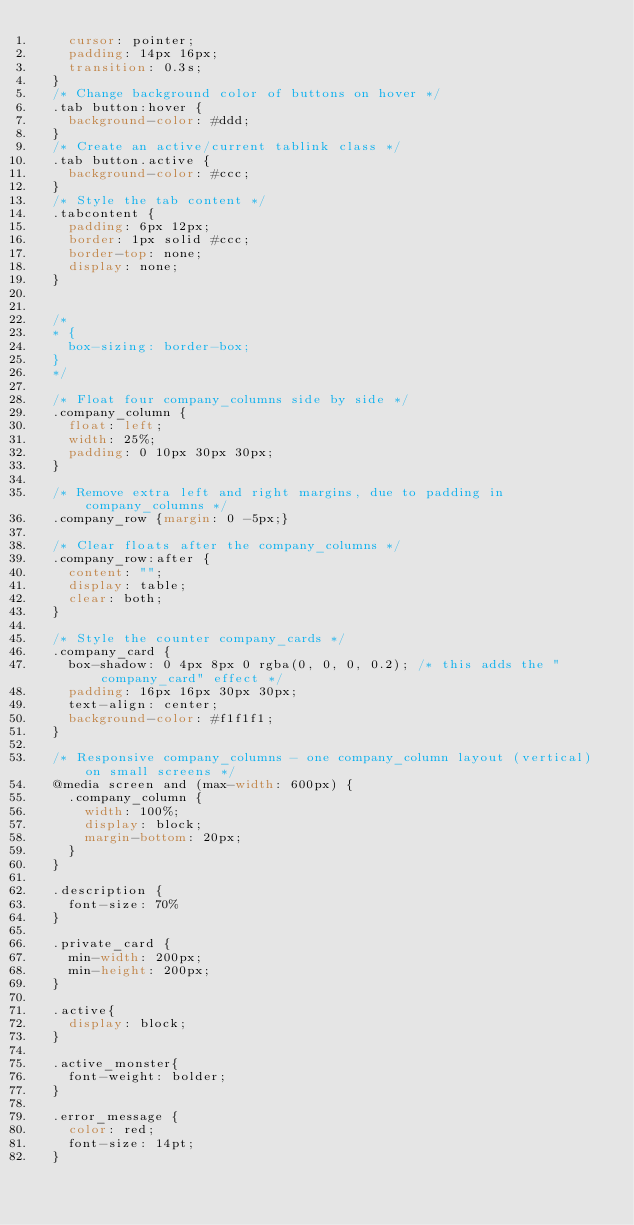<code> <loc_0><loc_0><loc_500><loc_500><_CSS_>    cursor: pointer;
    padding: 14px 16px;
    transition: 0.3s;
  }
  /* Change background color of buttons on hover */
  .tab button:hover {
    background-color: #ddd;
  }
  /* Create an active/current tablink class */
  .tab button.active {
    background-color: #ccc;
  }
  /* Style the tab content */
  .tabcontent {
    padding: 6px 12px;
    border: 1px solid #ccc;
    border-top: none;
    display: none;
  }


  /*
  * {
    box-sizing: border-box;
  }
  */

  /* Float four company_columns side by side */
  .company_column {
    float: left;
    width: 25%;
    padding: 0 10px 30px 30px;
  }
  
  /* Remove extra left and right margins, due to padding in company_columns */
  .company_row {margin: 0 -5px;}
  
  /* Clear floats after the company_columns */
  .company_row:after {
    content: "";
    display: table;
    clear: both;
  }
  
  /* Style the counter company_cards */
  .company_card {
    box-shadow: 0 4px 8px 0 rgba(0, 0, 0, 0.2); /* this adds the "company_card" effect */
    padding: 16px 16px 30px 30px;
    text-align: center;
    background-color: #f1f1f1;
  }
  
  /* Responsive company_columns - one company_column layout (vertical) on small screens */
  @media screen and (max-width: 600px) {
    .company_column {
      width: 100%;
      display: block;
      margin-bottom: 20px;
    }
  }

  .description {
    font-size: 70%
  }

  .private_card {
    min-width: 200px;
    min-height: 200px;
  }

  .active{
    display: block;
  }

  .active_monster{
    font-weight: bolder;
  }

  .error_message {
    color: red;
    font-size: 14pt;
  }</code> 